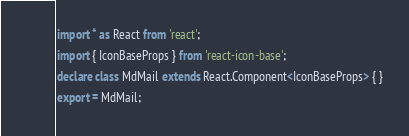Convert code to text. <code><loc_0><loc_0><loc_500><loc_500><_TypeScript_>import * as React from 'react';
import { IconBaseProps } from 'react-icon-base';
declare class MdMail extends React.Component<IconBaseProps> { }
export = MdMail;
</code> 